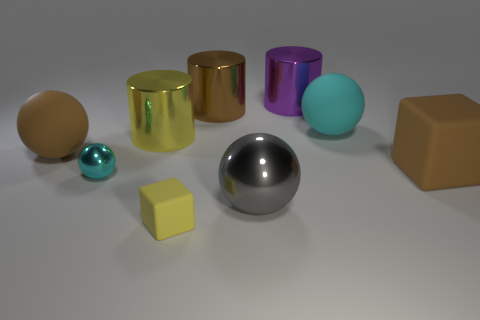Subtract 1 spheres. How many spheres are left? 3 Subtract all gray balls. How many balls are left? 3 Subtract all big balls. How many balls are left? 1 Subtract all green balls. Subtract all purple cylinders. How many balls are left? 4 Add 1 brown balls. How many objects exist? 10 Subtract all balls. How many objects are left? 5 Subtract all brown shiny things. Subtract all shiny spheres. How many objects are left? 6 Add 4 yellow matte objects. How many yellow matte objects are left? 5 Add 7 big brown matte objects. How many big brown matte objects exist? 9 Subtract 0 red cubes. How many objects are left? 9 